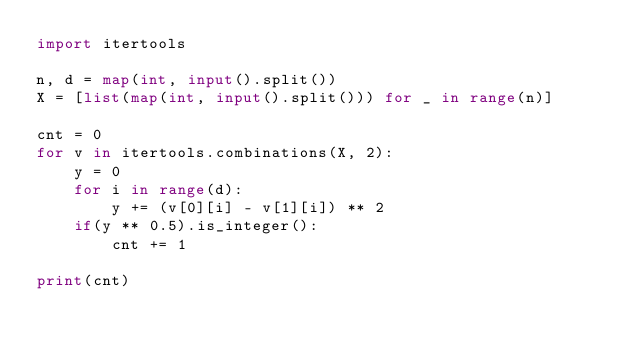<code> <loc_0><loc_0><loc_500><loc_500><_Python_>import itertools

n, d = map(int, input().split())
X = [list(map(int, input().split())) for _ in range(n)]

cnt = 0
for v in itertools.combinations(X, 2):
    y = 0
    for i in range(d):
        y += (v[0][i] - v[1][i]) ** 2
    if(y ** 0.5).is_integer():
        cnt += 1

print(cnt)</code> 